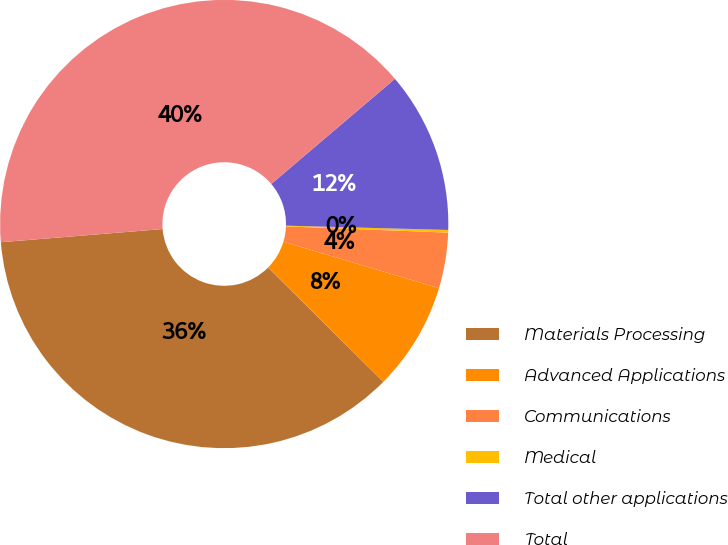Convert chart to OTSL. <chart><loc_0><loc_0><loc_500><loc_500><pie_chart><fcel>Materials Processing<fcel>Advanced Applications<fcel>Communications<fcel>Medical<fcel>Total other applications<fcel>Total<nl><fcel>36.27%<fcel>7.82%<fcel>4.01%<fcel>0.19%<fcel>11.64%<fcel>40.08%<nl></chart> 